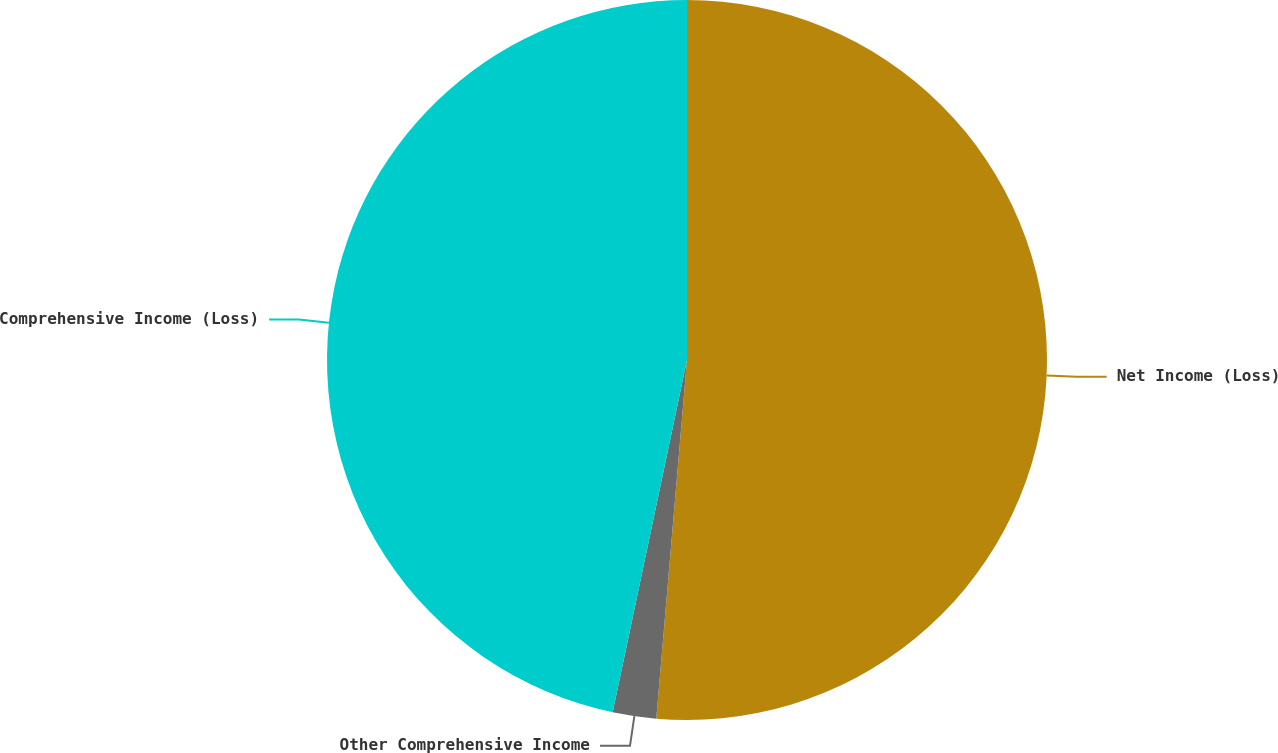Convert chart to OTSL. <chart><loc_0><loc_0><loc_500><loc_500><pie_chart><fcel>Net Income (Loss)<fcel>Other Comprehensive Income<fcel>Comprehensive Income (Loss)<nl><fcel>51.36%<fcel>1.95%<fcel>46.69%<nl></chart> 